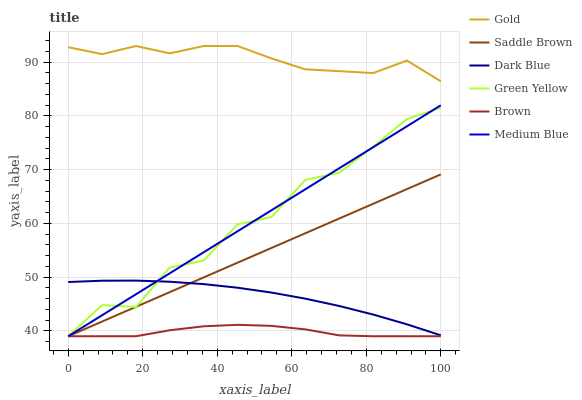Does Brown have the minimum area under the curve?
Answer yes or no. Yes. Does Gold have the maximum area under the curve?
Answer yes or no. Yes. Does Medium Blue have the minimum area under the curve?
Answer yes or no. No. Does Medium Blue have the maximum area under the curve?
Answer yes or no. No. Is Saddle Brown the smoothest?
Answer yes or no. Yes. Is Green Yellow the roughest?
Answer yes or no. Yes. Is Gold the smoothest?
Answer yes or no. No. Is Gold the roughest?
Answer yes or no. No. Does Brown have the lowest value?
Answer yes or no. Yes. Does Gold have the lowest value?
Answer yes or no. No. Does Gold have the highest value?
Answer yes or no. Yes. Does Medium Blue have the highest value?
Answer yes or no. No. Is Brown less than Gold?
Answer yes or no. Yes. Is Dark Blue greater than Brown?
Answer yes or no. Yes. Does Medium Blue intersect Dark Blue?
Answer yes or no. Yes. Is Medium Blue less than Dark Blue?
Answer yes or no. No. Is Medium Blue greater than Dark Blue?
Answer yes or no. No. Does Brown intersect Gold?
Answer yes or no. No. 